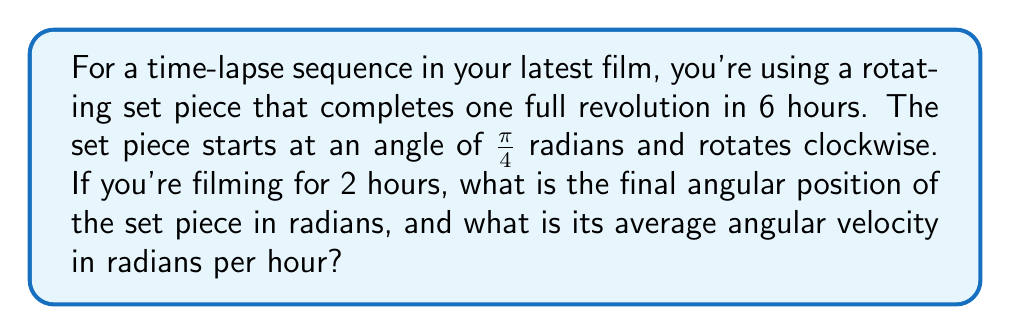Can you solve this math problem? Let's approach this problem step by step:

1) First, we need to calculate the angular velocity of the set piece.
   One full revolution = $2\pi$ radians
   Time for one revolution = 6 hours
   
   Angular velocity = $\omega = \frac{2\pi}{6} = \frac{\pi}{3}$ radians per hour

2) Note that the set piece is rotating clockwise, which means the angle is decreasing over time. So we need to use a negative angular velocity.

3) Now, let's calculate the change in angle over 2 hours:
   $\Delta \theta = \omega \cdot t = -\frac{\pi}{3} \cdot 2 = -\frac{2\pi}{3}$ radians

4) The initial angle is $\frac{\pi}{4}$ radians. To find the final angle:
   $\theta_{final} = \theta_{initial} + \Delta \theta = \frac{\pi}{4} - \frac{2\pi}{3} = \frac{3\pi}{12} - \frac{8\pi}{12} = -\frac{5\pi}{12}$ radians

5) The average angular velocity is the same as the constant angular velocity we calculated in step 1, which is $-\frac{\pi}{3}$ radians per hour.
Answer: The final angular position of the set piece is $-\frac{5\pi}{12}$ radians, and its average angular velocity is $-\frac{\pi}{3}$ radians per hour. 